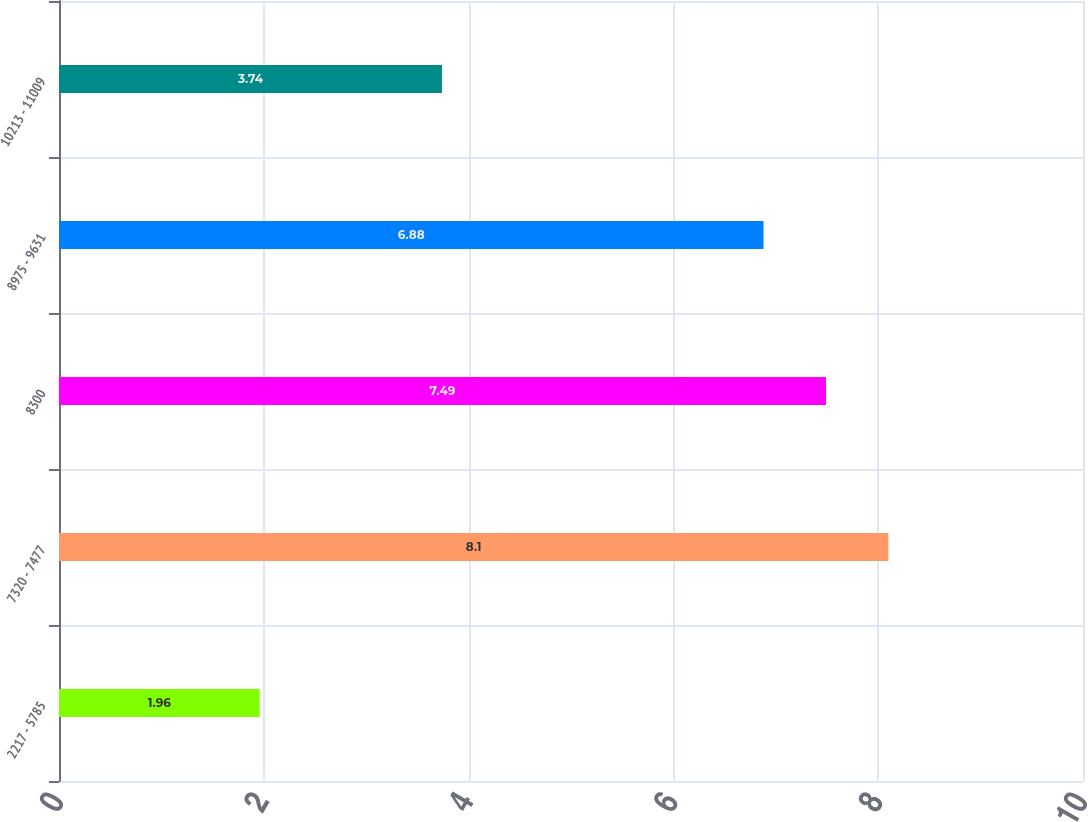Convert chart to OTSL. <chart><loc_0><loc_0><loc_500><loc_500><bar_chart><fcel>2217 - 5785<fcel>7320 - 7477<fcel>8300<fcel>8975 - 9631<fcel>10213 - 11009<nl><fcel>1.96<fcel>8.1<fcel>7.49<fcel>6.88<fcel>3.74<nl></chart> 